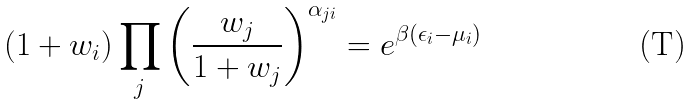Convert formula to latex. <formula><loc_0><loc_0><loc_500><loc_500>( 1 + w _ { i } ) \prod _ { j } \left ( \frac { w _ { j } } { 1 + w _ { j } } \right ) ^ { \alpha _ { j i } } = e ^ { \beta ( \epsilon _ { i } - \mu _ { i } ) }</formula> 